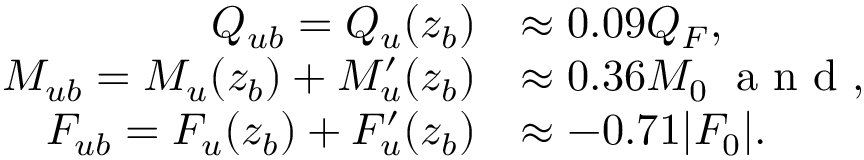<formula> <loc_0><loc_0><loc_500><loc_500>\begin{array} { r l } { Q _ { u b } = Q _ { u } ( z _ { b } ) } & { \approx 0 . 0 9 Q _ { F } , } \\ { M _ { u b } = M _ { u } ( z _ { b } ) + M _ { u } ^ { \prime } ( z _ { b } ) } & { \approx 0 . 3 6 M _ { 0 } \, a n d , } \\ { F _ { u b } = F _ { u } ( z _ { b } ) + F _ { u } ^ { \prime } ( z _ { b } ) } & { \approx - 0 . 7 1 | F _ { 0 } | . } \end{array}</formula> 